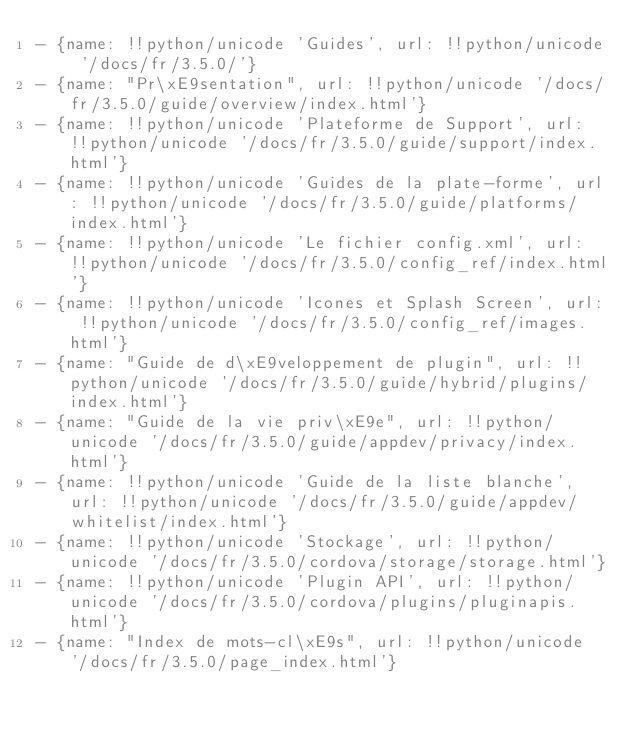<code> <loc_0><loc_0><loc_500><loc_500><_YAML_>- {name: !!python/unicode 'Guides', url: !!python/unicode '/docs/fr/3.5.0/'}
- {name: "Pr\xE9sentation", url: !!python/unicode '/docs/fr/3.5.0/guide/overview/index.html'}
- {name: !!python/unicode 'Plateforme de Support', url: !!python/unicode '/docs/fr/3.5.0/guide/support/index.html'}
- {name: !!python/unicode 'Guides de la plate-forme', url: !!python/unicode '/docs/fr/3.5.0/guide/platforms/index.html'}
- {name: !!python/unicode 'Le fichier config.xml', url: !!python/unicode '/docs/fr/3.5.0/config_ref/index.html'}
- {name: !!python/unicode 'Icones et Splash Screen', url: !!python/unicode '/docs/fr/3.5.0/config_ref/images.html'}
- {name: "Guide de d\xE9veloppement de plugin", url: !!python/unicode '/docs/fr/3.5.0/guide/hybrid/plugins/index.html'}
- {name: "Guide de la vie priv\xE9e", url: !!python/unicode '/docs/fr/3.5.0/guide/appdev/privacy/index.html'}
- {name: !!python/unicode 'Guide de la liste blanche', url: !!python/unicode '/docs/fr/3.5.0/guide/appdev/whitelist/index.html'}
- {name: !!python/unicode 'Stockage', url: !!python/unicode '/docs/fr/3.5.0/cordova/storage/storage.html'}
- {name: !!python/unicode 'Plugin API', url: !!python/unicode '/docs/fr/3.5.0/cordova/plugins/pluginapis.html'}
- {name: "Index de mots-cl\xE9s", url: !!python/unicode '/docs/fr/3.5.0/page_index.html'}
</code> 